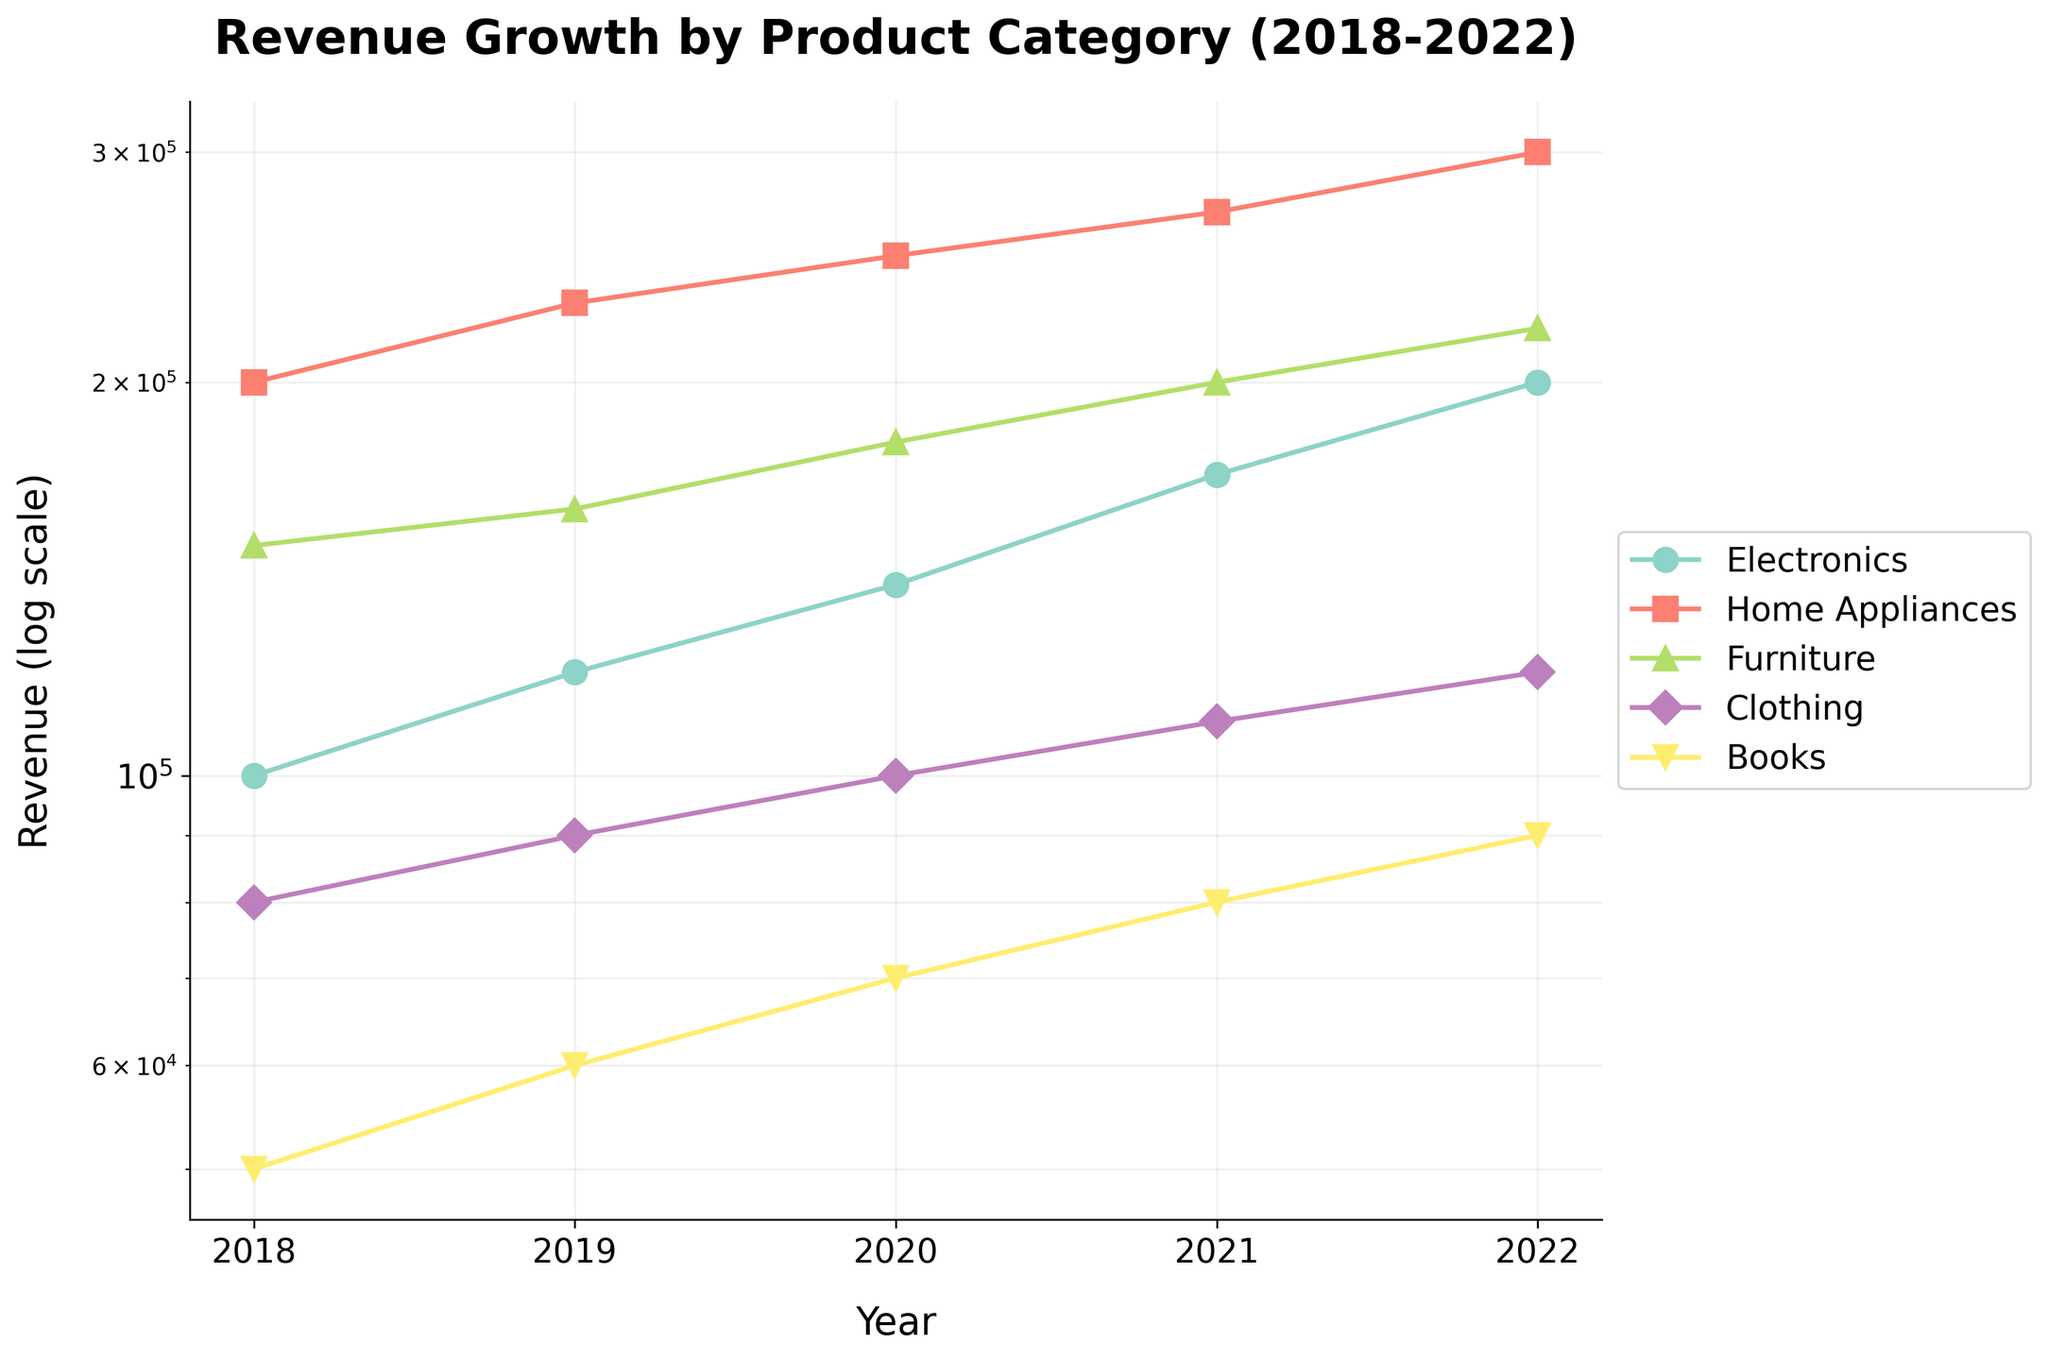Which category has the highest revenue in 2022? The log plot shows that the "Home Appliances" category has the highest revenue point in 2022.
Answer: Home Appliances What is the title of the plot? The title is located at the top of the plot and reads "Revenue Growth by Product Category (2018-2022)".
Answer: Revenue Growth by Product Category (2018-2022) How many different product categories are represented in the plot? The legend on the right side of the plot shows five different categories: Electronics, Home Appliances, Furniture, Clothing, and Books.
Answer: 5 Which category shows consistent growth every year from 2018 to 2022? By following the log-scaled lines for each category, "Home Appliances" reveals consistent growth across each year.
Answer: Home Appliances How does the revenue of the "Books" category in 2018 compare to 2022? According to the log plot, the revenue for "Books" increases from 50,000 in 2018 to 90,000 in 2022.
Answer: It increases Order the categories by their revenue in 2020 from highest to lowest. Check the revenue points for each category in 2020 and sort them: Home Appliances, Furniture, Electronics, Clothing, Books.
Answer: Home Appliances, Furniture, Electronics, Clothing, Books Which category experienced the largest percentage increase in revenue from 2018 to 2022? Calculate the percentage increase for each category. For "Books," it increased from 50,000 to 90,000, which is an 80% increase. By comparing all categories, "Electronics" grew from 100,000 to 200,000, which is 100%. Therefore, "Electronics" has the largest percentage increase.
Answer: Electronics For what years does the "Furniture" category have higher revenue than the "Clothing" category? Check the intersection points of "Furniture" and "Clothing" lines; "Furniture" has higher revenue than "Clothing" in all years: 2018, 2019, 2020, 2021, and 2022.
Answer: 2018, 2019, 2020, 2021, 2022 